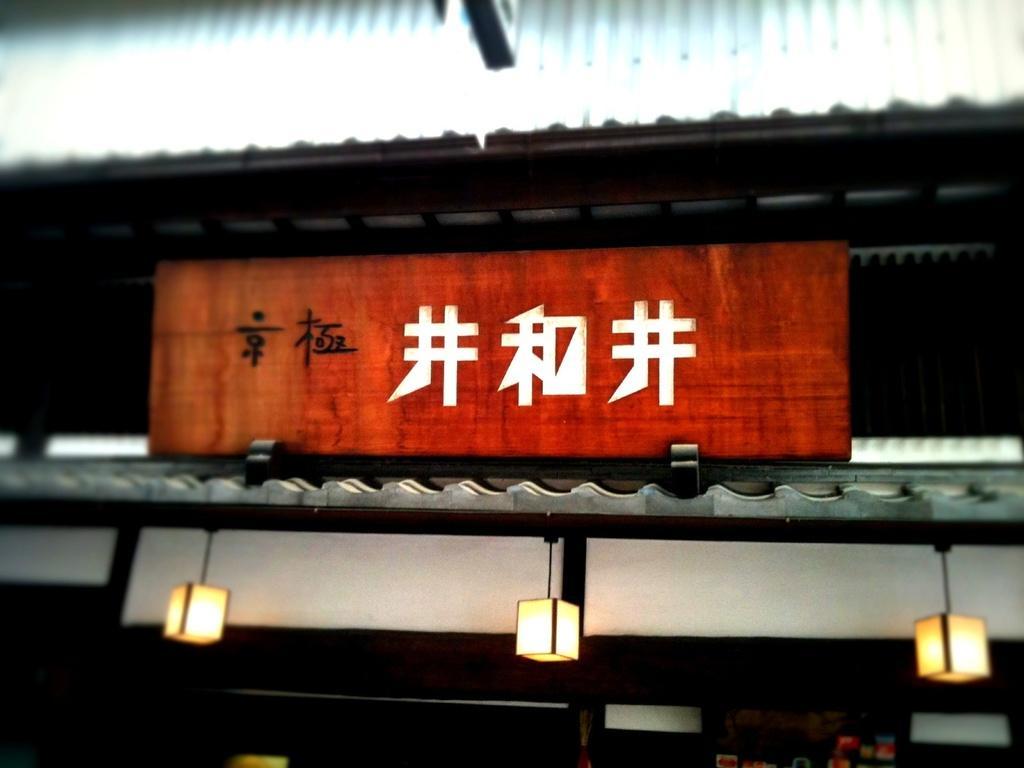Can you describe this image briefly? In this image, we can see the shed and a board with some text. We can see the wall and some lights. We can see some objects at the bottom. 